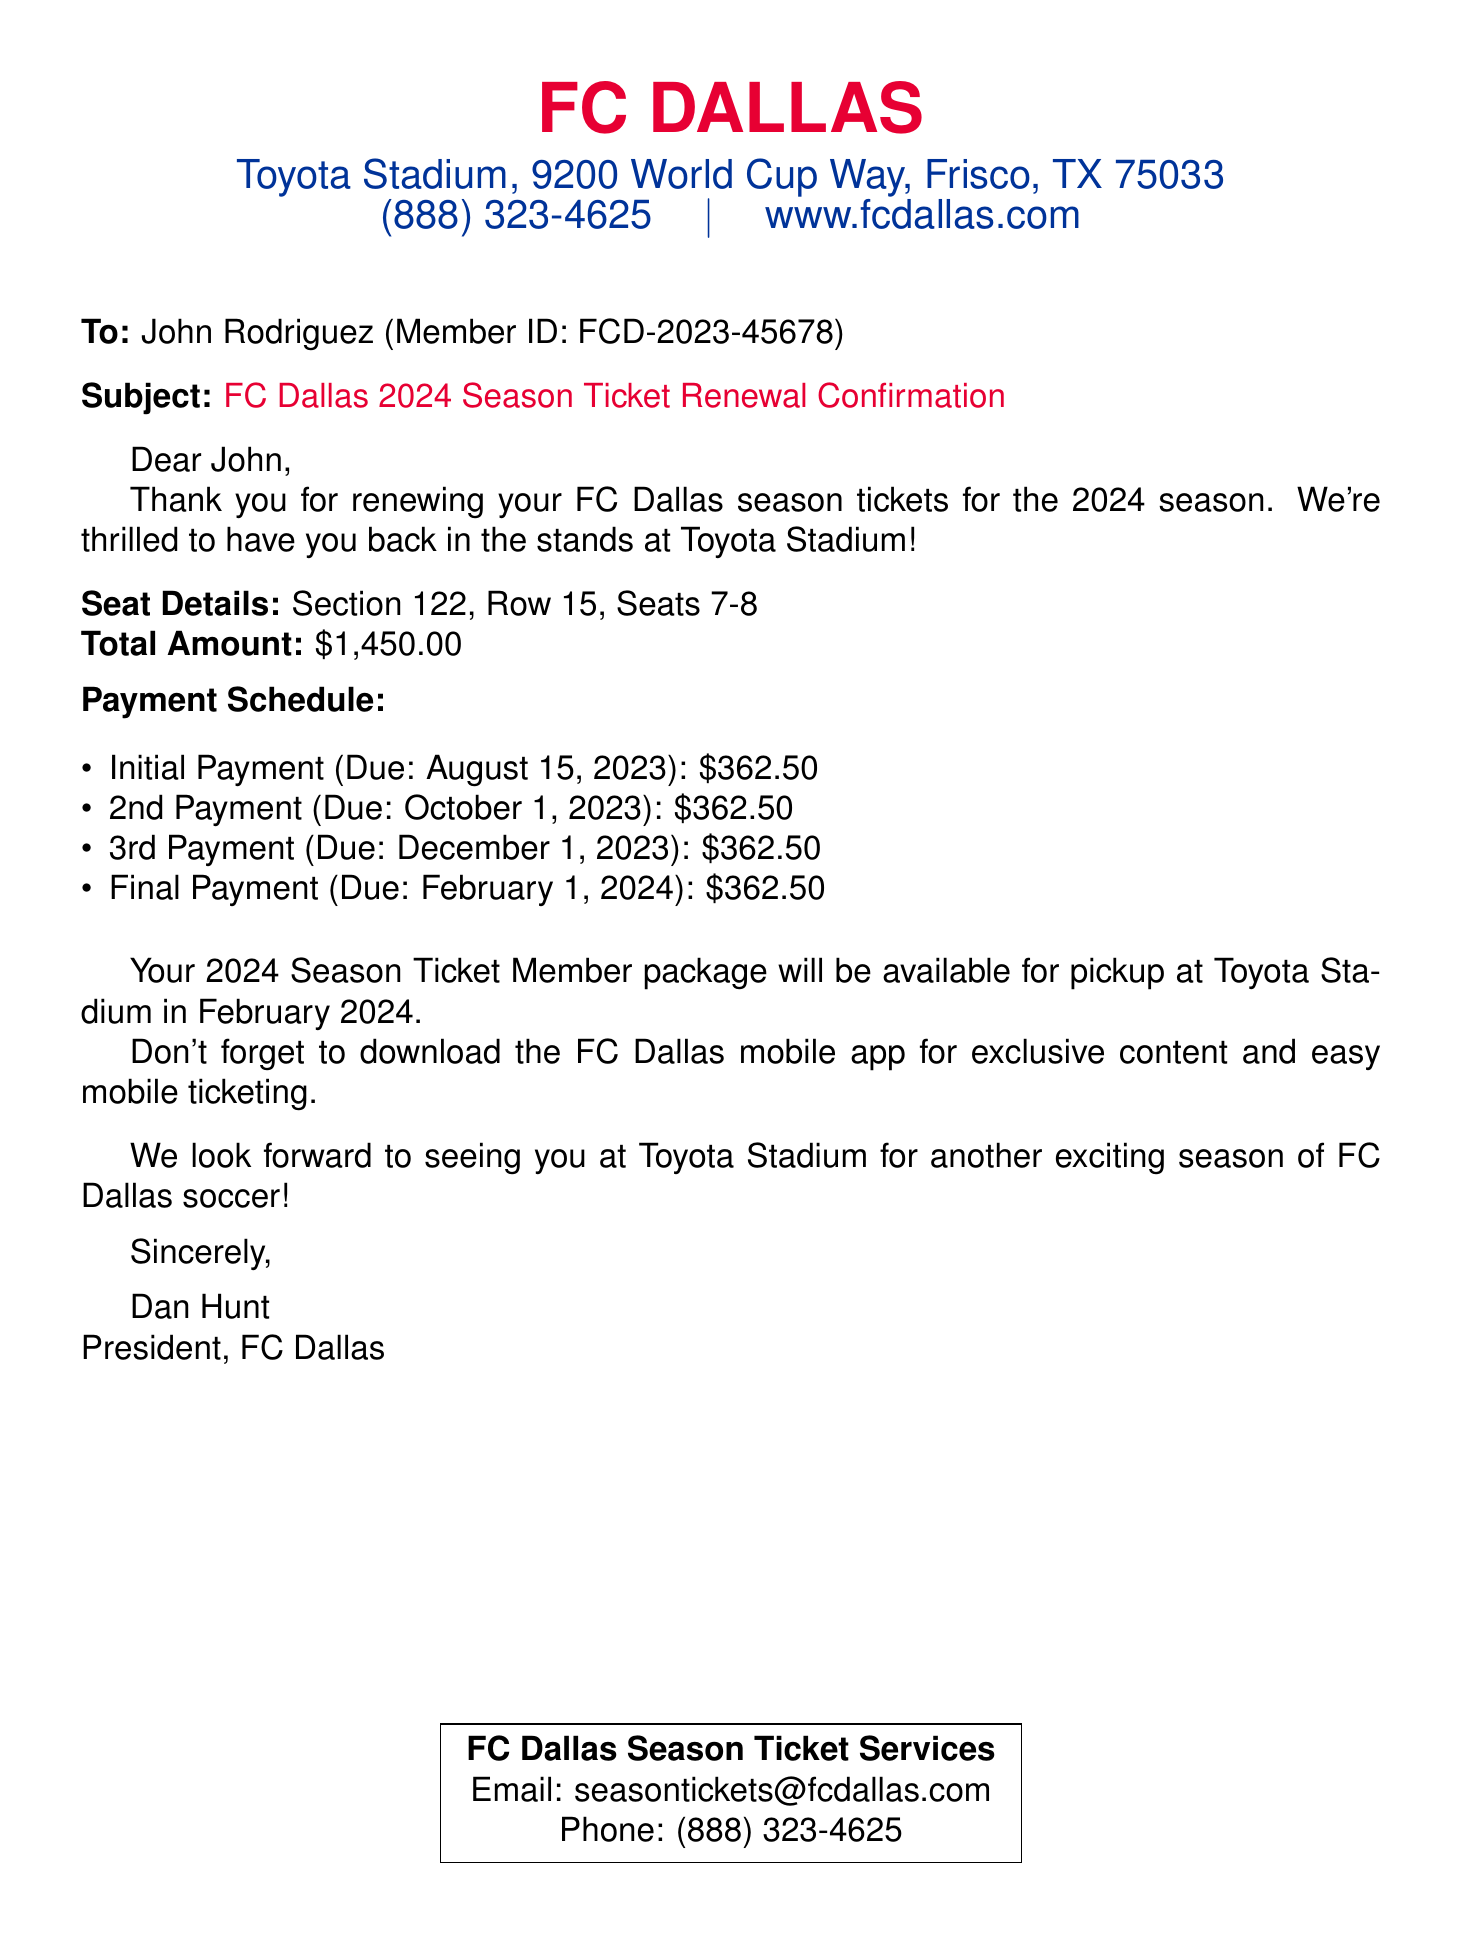What is the total amount for the season ticket renewal? The total amount for the season ticket renewal is specified in the document.
Answer: $1,450.00 What is the member ID for John Rodriguez? The member ID is listed in the document under his name.
Answer: FCD-2023-45678 How many payments are scheduled for the season ticket renewal? The payment schedule in the document lists a total of four payments.
Answer: 4 What is the due date for the final payment? The due date for the final payment is outlined in the payment schedule.
Answer: February 1, 2024 In which section are the seats located? The document provides specific seat details, including the section number.
Answer: Section 122 Who is the president of FC Dallas? The document identifies the president of FC Dallas at the bottom.
Answer: Dan Hunt What is the name of the stadium? The name of the stadium is mentioned at the top of the document.
Answer: Toyota Stadium When will the member package be available for pickup? The pickup date for the member package is stated in the document.
Answer: February 2024 What should fans download for exclusive content? The document encourages downloading a specific app for fans.
Answer: FC Dallas mobile app 